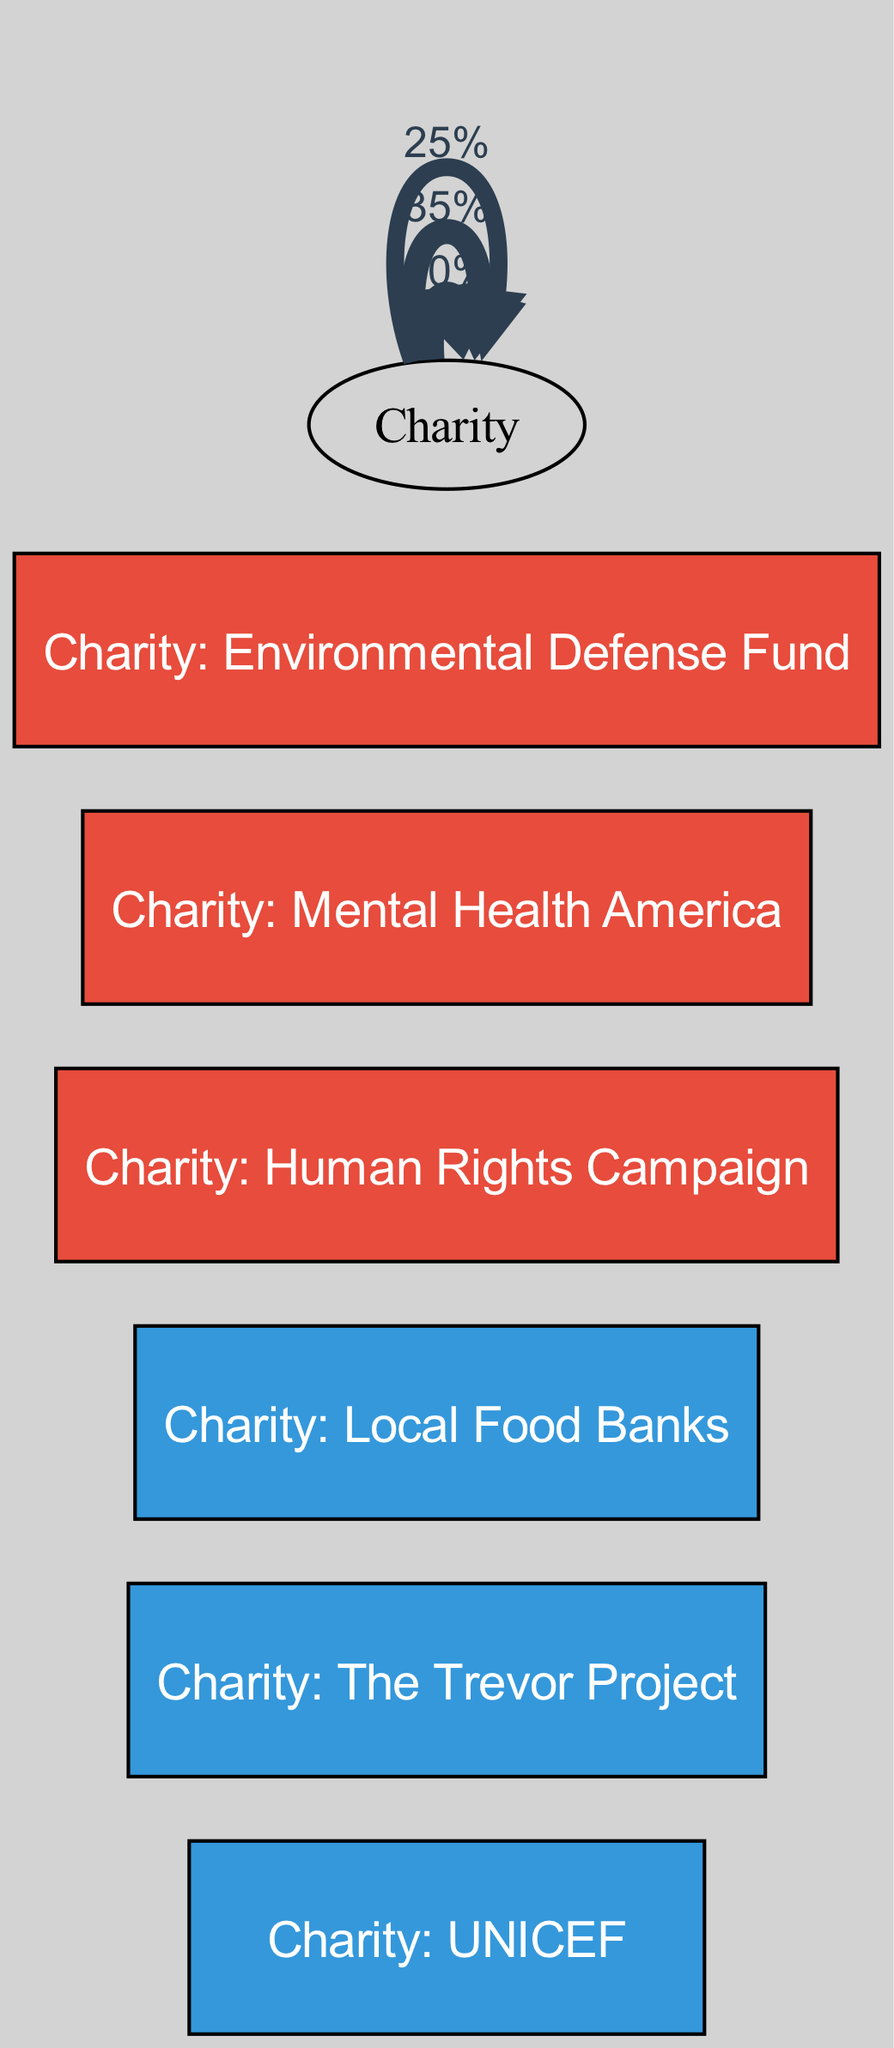What are the three charities before falling from grace? The nodes identified as "Before" are the charities listed: UNICEF, The Trevor Project, and Local Food Banks.
Answer: UNICEF, The Trevor Project, Local Food Banks What is the target charity connected to UNICEF? The link from UNICEF shows that it is connected to the Human Rights Campaign, indicated by the diagram's flow.
Answer: Human Rights Campaign How many nodes are depicted in the diagram? By counting both the "Before" and "After" nodes, there are a total of six nodes: three from "Before" and three from "After."
Answer: 6 Which charity received the largest percentage contribution? The largest percentage is 40% flowing from UNICEF to the Human Rights Campaign, as represented by the thickest edge in the diagram.
Answer: 40% What is the total percentage of contribution from Local Food Banks? The only contribution from Local Food Banks flows to the Environmental Defense Fund, which is 25%.
Answer: 25% What is the relationship between The Trevor Project and Mental Health America? The Trevor Project connects to Mental Health America via a flow of 35%, representing a significant shift in philanthropic focus after falling from grace.
Answer: 35% Which charity did not receive any contributions after the fall from grace? UNICEF and The Trevor Project do not appear as target nodes in the "After" category, indicating they did not receive contributions post-fall.
Answer: UNICEF, The Trevor Project Which "After" charity is connected to the highest percentage source? The Human Rights Campaign is connected to the highest percentage source (40%) from UNICEF, showcasing a significant change in focus.
Answer: Human Rights Campaign 